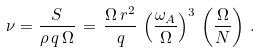Convert formula to latex. <formula><loc_0><loc_0><loc_500><loc_500>\nu = \frac { S } { \rho \, q \, \Omega } \, = \, \frac { \Omega \, r ^ { 2 } } { q } \, \left ( \frac { \omega _ { A } } { \Omega } \right ) ^ { 3 } \, \left ( \frac { \Omega } { N } \right ) \, .</formula> 